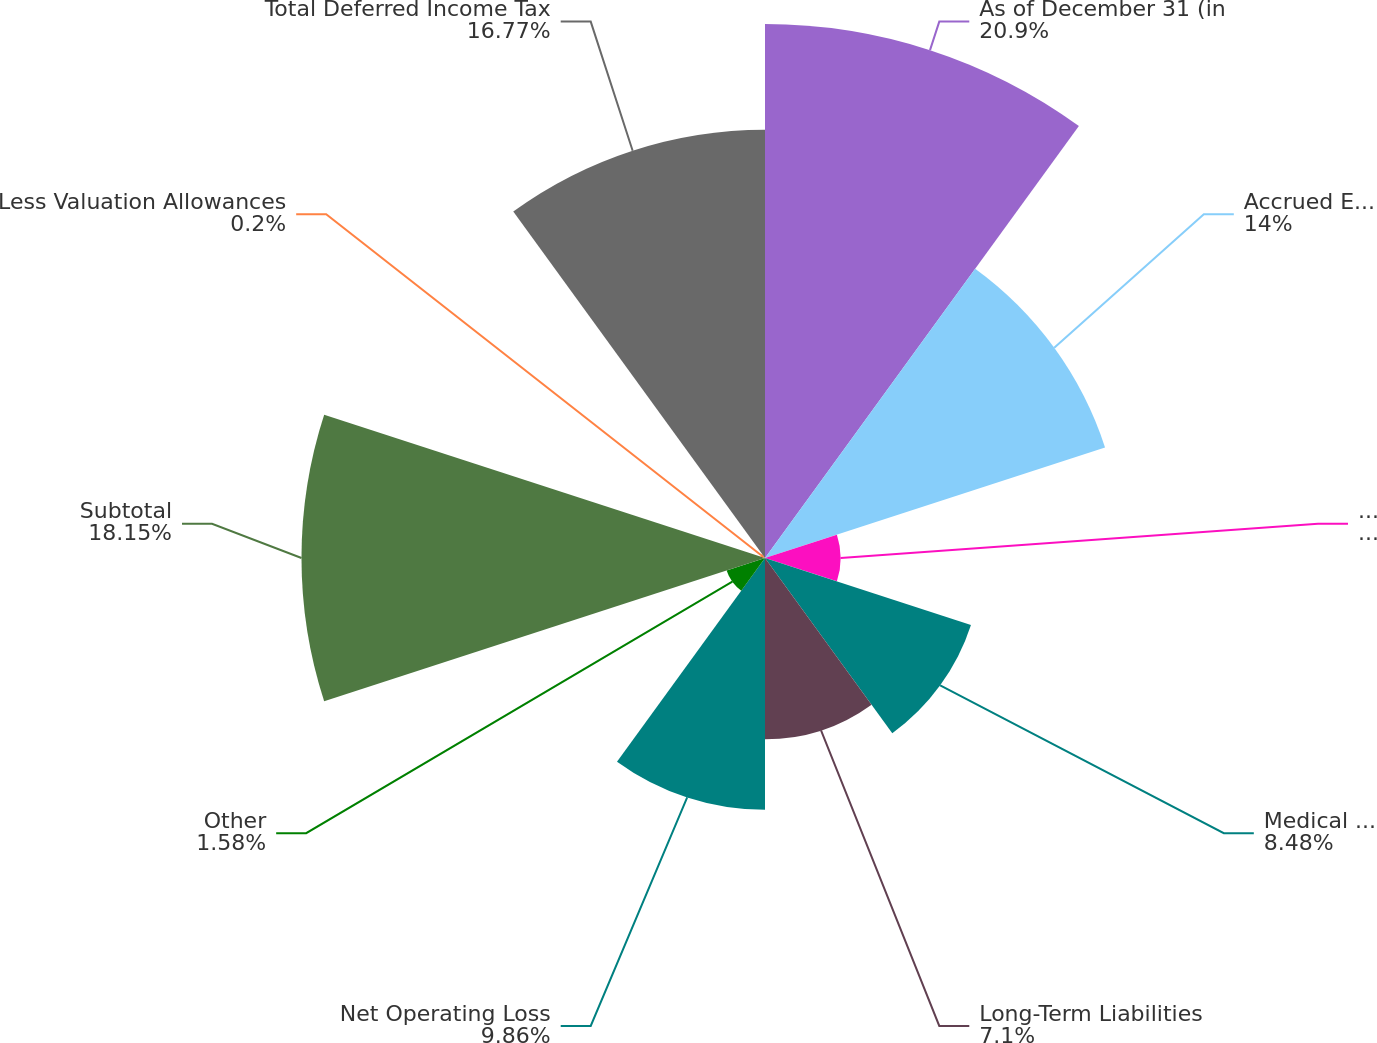Convert chart. <chart><loc_0><loc_0><loc_500><loc_500><pie_chart><fcel>As of December 31 (in<fcel>Accrued Expenses and<fcel>Unearned Premiums<fcel>Medical Costs Payable and<fcel>Long-Term Liabilities<fcel>Net Operating Loss<fcel>Other<fcel>Subtotal<fcel>Less Valuation Allowances<fcel>Total Deferred Income Tax<nl><fcel>20.91%<fcel>14.0%<fcel>2.96%<fcel>8.48%<fcel>7.1%<fcel>9.86%<fcel>1.58%<fcel>18.15%<fcel>0.2%<fcel>16.77%<nl></chart> 